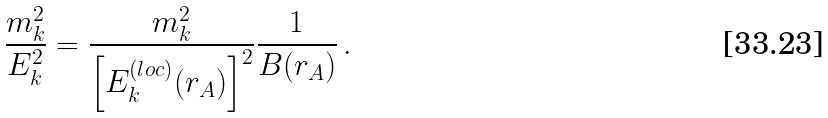<formula> <loc_0><loc_0><loc_500><loc_500>\frac { m ^ { 2 } _ { k } } { E ^ { 2 } _ { k } } = \frac { m ^ { 2 } _ { k } } { \left [ E ^ { ( l o c ) } _ { k } ( r _ { A } ) \right ] ^ { 2 } } \frac { 1 } { B ( r _ { A } ) } \, .</formula> 